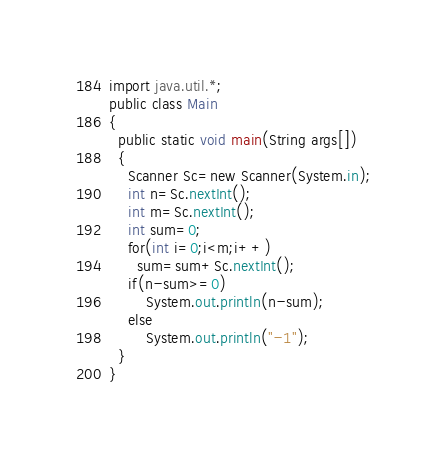<code> <loc_0><loc_0><loc_500><loc_500><_Java_>import java.util.*;
public class Main
{
  public static void main(String args[])
  {
    Scanner Sc=new Scanner(System.in);
    int n=Sc.nextInt();
    int m=Sc.nextInt();
    int sum=0;
    for(int i=0;i<m;i++)
      sum=sum+Sc.nextInt();
   	if(n-sum>=0)
    	System.out.println(n-sum);
    else
    	System.out.println("-1");
  }
}
</code> 